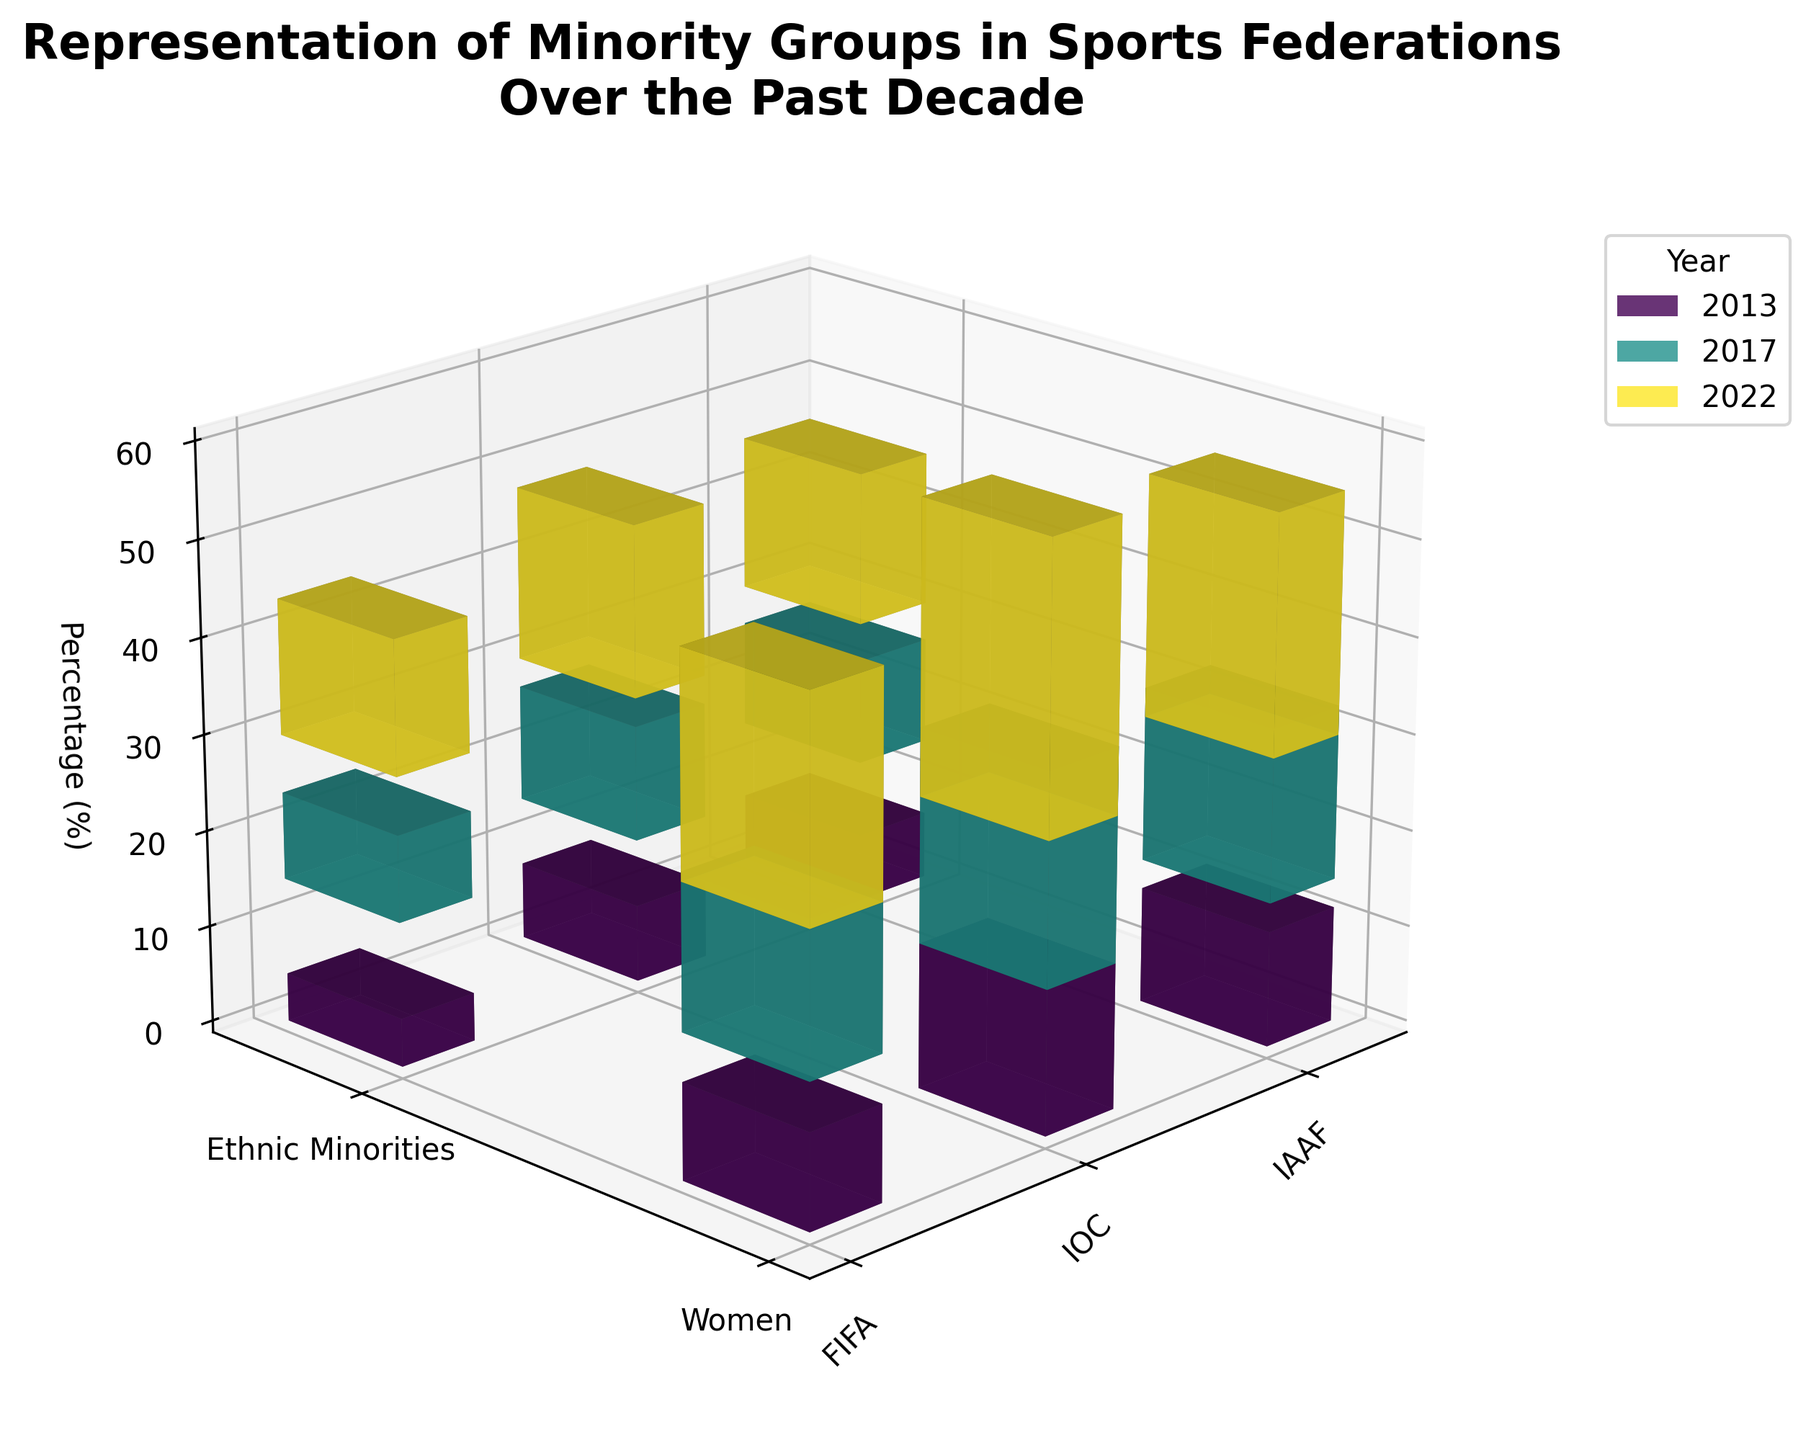How many years does the data span in this plot? The plot shows bars for each year and the data labels on the legend indicate the years included.
Answer: 3 years What's the title of the figure? The title is displayed at the top of the figure.
Answer: Representation of Minority Groups in Sports Federations Over the Past Decade Which federation has the highest percentage of women in leadership positions in 2022? In 2022, compare the highest bar for women across all federations.
Answer: IOC How does the percentage of ethnic minorities in leadership positions in FIFA change from 2013 to 2022? Compare the heights of the bars for ethnic minorities in FIFA for the years 2013, 2017, and 2022.
Answer: It increases from 5% in 2013 to 14% in 2022 What is the difference in the percentage of women in leadership positions between the IOC and IAAF in 2017? Subtract the percentage of women in the IAAF from that in the IOC for the year 2017.
Answer: 4% Which minority group in which federation saw the biggest increase in percentage points from 2013 to 2022? Calculate the difference for each group in each federation between 2013 and 2022, then find the highest difference.
Answer: IOC Women What is the average percentage of ethnic minorities in FIFA over the years provided? Calculate the mean of the percentages for ethnic minorities in FIFA for the years 2013, 2017, and 2022.
Answer: (5 + 9 + 14) / 3 = 9.33% Which year saw the largest increase in the percentage of women in the IAAF from the previous recorded year? Compare the differences between consecutive years for women's percentages in IAAF.
Answer: 2017 Among the federations, which one showed the least improvement in the percentage of ethnic minorities from 2013 to 2022? Calculate the improvement for ethnic minorities in all federations and find the smallest value.
Answer: IAAF (9%) What is the combined percentage of women and ethnic minorities in leadership positions in the IOC in 2022? Add the percentage of women and ethnic minorities in the IOC for 2022.
Answer: 48% 